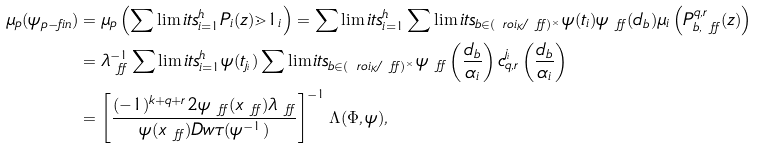Convert formula to latex. <formula><loc_0><loc_0><loc_500><loc_500>\mu _ { p } ( \psi _ { p - f i n } ) & = \mu _ { p } \left ( \sum \lim i t s _ { i = 1 } ^ { h } P _ { i } ( z ) \mathbb { m } { 1 } _ { i } \right ) = \sum \lim i t s _ { i = 1 } ^ { h } \sum \lim i t s _ { b \in ( \ r o i _ { K } / \ f f ) ^ { \times } } \psi ( t _ { i } ) \psi _ { \ f f } ( d _ { b } ) \mu _ { i } \left ( P _ { b , \ f f } ^ { q , r } ( z ) \right ) \\ & = \lambda _ { \ f f } ^ { - 1 } \sum \lim i t s _ { i = 1 } ^ { h } \psi ( t _ { j _ { i } } ) \sum \lim i t s _ { b \in ( \ r o i _ { K } / \ f f ) ^ { \times } } \psi _ { \ f f } \left ( \frac { d _ { b } } { \alpha _ { i } } \right ) c _ { q , r } ^ { j _ { i } } \left ( \frac { d _ { b } } { \alpha _ { i } } \right ) \\ & = \left [ \frac { ( - 1 ) ^ { k + q + r } 2 \psi _ { \ f f } ( x _ { \ f f } ) \lambda _ { \ f f } } { \psi ( x _ { \ f f } ) D w \tau ( \psi ^ { - 1 } ) } \right ] ^ { - 1 } \Lambda ( \Phi , \psi ) ,</formula> 